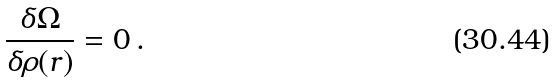<formula> <loc_0><loc_0><loc_500><loc_500>\frac { \delta \Omega } { \delta \rho ( { r } ) } = 0 \, .</formula> 